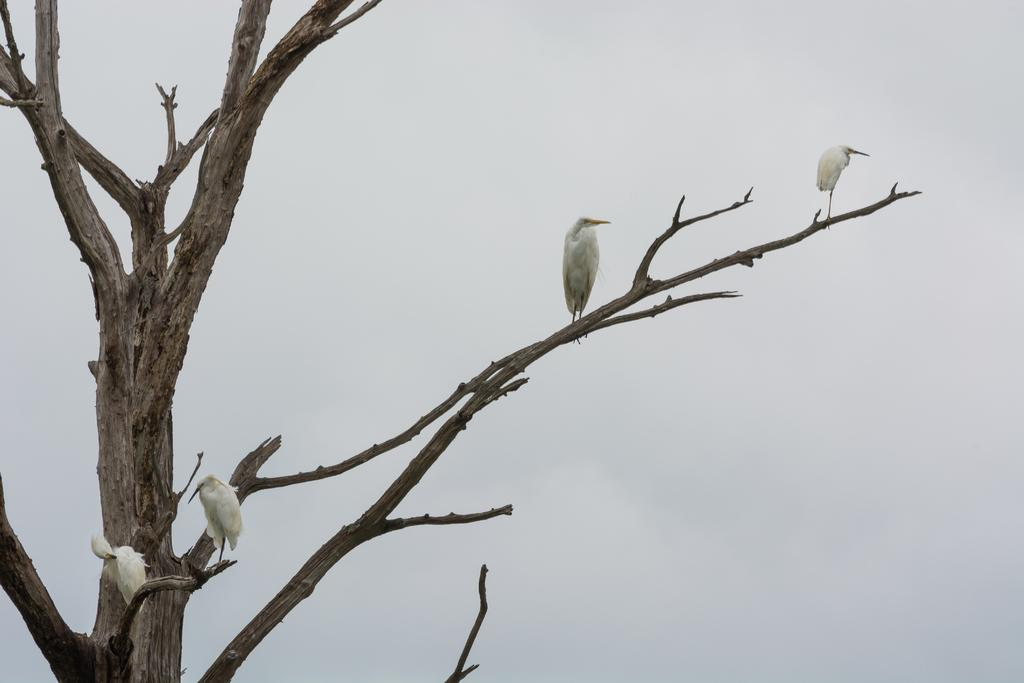What type of animals can be seen in the image? There are birds on the tree in the image. What can be seen in the background of the image? The sky is visible in the background of the image. What is the best route to the sea from the location of the birds in the image? There is no information about a sea or a route in the image, so it is not possible to answer that question. 